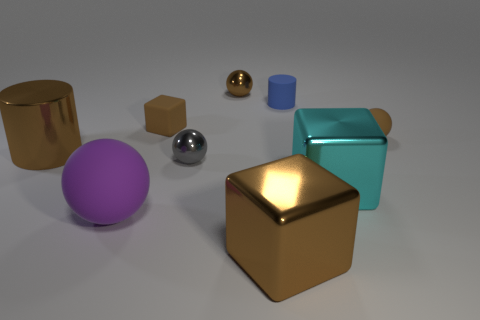Subtract all brown cubes. How many cubes are left? 1 Subtract all balls. How many objects are left? 5 Subtract all purple spheres. How many spheres are left? 3 Subtract all yellow cubes. How many brown spheres are left? 2 Add 5 big cyan blocks. How many big cyan blocks are left? 6 Add 7 cyan cubes. How many cyan cubes exist? 8 Subtract 1 gray balls. How many objects are left? 8 Subtract 3 cubes. How many cubes are left? 0 Subtract all gray cubes. Subtract all green cylinders. How many cubes are left? 3 Subtract all gray rubber cylinders. Subtract all tiny shiny balls. How many objects are left? 7 